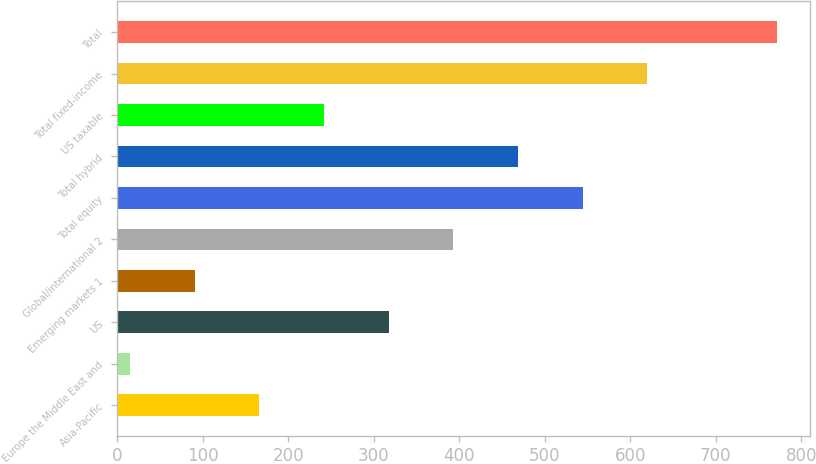Convert chart. <chart><loc_0><loc_0><loc_500><loc_500><bar_chart><fcel>Asia-Pacific<fcel>Europe the Middle East and<fcel>US<fcel>Emerging markets 1<fcel>Global/international 2<fcel>Total equity<fcel>Total hybrid<fcel>US taxable<fcel>Total fixed-income<fcel>Total<nl><fcel>166.26<fcel>15.1<fcel>317.42<fcel>90.68<fcel>393<fcel>544.16<fcel>468.58<fcel>241.84<fcel>619.74<fcel>770.9<nl></chart> 